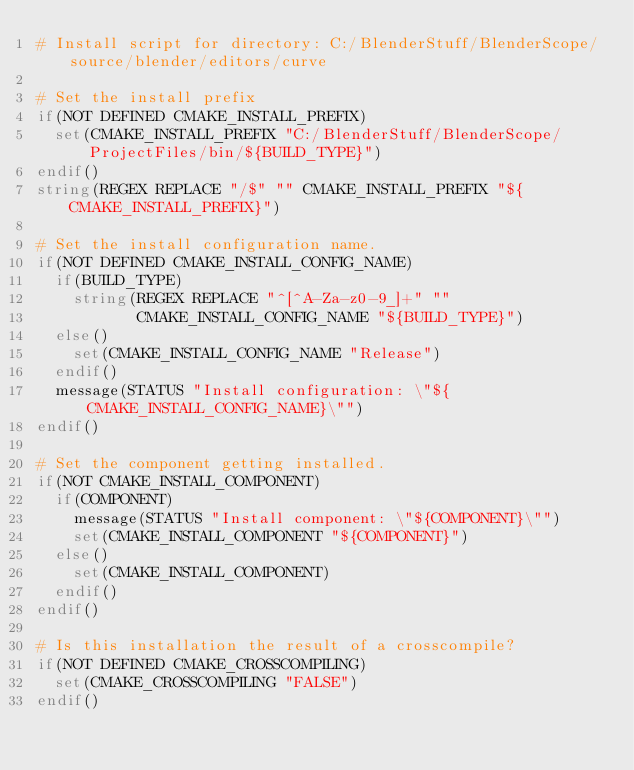Convert code to text. <code><loc_0><loc_0><loc_500><loc_500><_CMake_># Install script for directory: C:/BlenderStuff/BlenderScope/source/blender/editors/curve

# Set the install prefix
if(NOT DEFINED CMAKE_INSTALL_PREFIX)
  set(CMAKE_INSTALL_PREFIX "C:/BlenderStuff/BlenderScope/ProjectFiles/bin/${BUILD_TYPE}")
endif()
string(REGEX REPLACE "/$" "" CMAKE_INSTALL_PREFIX "${CMAKE_INSTALL_PREFIX}")

# Set the install configuration name.
if(NOT DEFINED CMAKE_INSTALL_CONFIG_NAME)
  if(BUILD_TYPE)
    string(REGEX REPLACE "^[^A-Za-z0-9_]+" ""
           CMAKE_INSTALL_CONFIG_NAME "${BUILD_TYPE}")
  else()
    set(CMAKE_INSTALL_CONFIG_NAME "Release")
  endif()
  message(STATUS "Install configuration: \"${CMAKE_INSTALL_CONFIG_NAME}\"")
endif()

# Set the component getting installed.
if(NOT CMAKE_INSTALL_COMPONENT)
  if(COMPONENT)
    message(STATUS "Install component: \"${COMPONENT}\"")
    set(CMAKE_INSTALL_COMPONENT "${COMPONENT}")
  else()
    set(CMAKE_INSTALL_COMPONENT)
  endif()
endif()

# Is this installation the result of a crosscompile?
if(NOT DEFINED CMAKE_CROSSCOMPILING)
  set(CMAKE_CROSSCOMPILING "FALSE")
endif()

</code> 